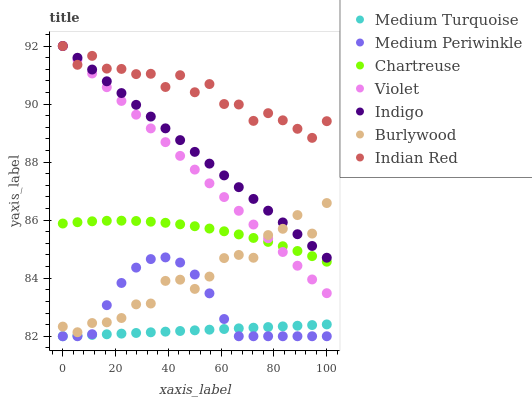Does Medium Turquoise have the minimum area under the curve?
Answer yes or no. Yes. Does Indian Red have the maximum area under the curve?
Answer yes or no. Yes. Does Burlywood have the minimum area under the curve?
Answer yes or no. No. Does Burlywood have the maximum area under the curve?
Answer yes or no. No. Is Violet the smoothest?
Answer yes or no. Yes. Is Indian Red the roughest?
Answer yes or no. Yes. Is Burlywood the smoothest?
Answer yes or no. No. Is Burlywood the roughest?
Answer yes or no. No. Does Medium Periwinkle have the lowest value?
Answer yes or no. Yes. Does Burlywood have the lowest value?
Answer yes or no. No. Does Violet have the highest value?
Answer yes or no. Yes. Does Burlywood have the highest value?
Answer yes or no. No. Is Medium Turquoise less than Indigo?
Answer yes or no. Yes. Is Burlywood greater than Medium Turquoise?
Answer yes or no. Yes. Does Indigo intersect Violet?
Answer yes or no. Yes. Is Indigo less than Violet?
Answer yes or no. No. Is Indigo greater than Violet?
Answer yes or no. No. Does Medium Turquoise intersect Indigo?
Answer yes or no. No. 